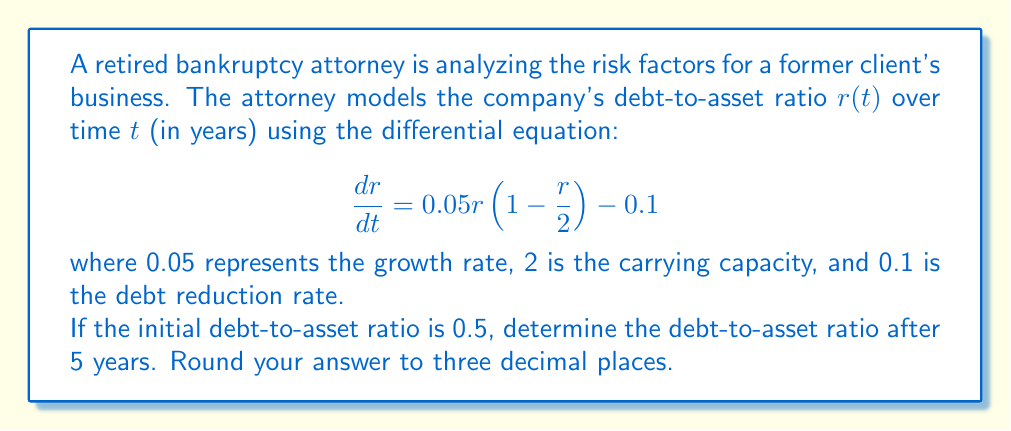Help me with this question. To solve this problem, we need to use the given differential equation and initial condition to find the debt-to-asset ratio after 5 years. This is a logistic differential equation with an additional constant term.

1. First, let's rearrange the equation:
   $$\frac{dr}{dt} = 0.05r - 0.025r^2 - 0.1$$

2. This is a Bernoulli differential equation. We can solve it by using the substitution $u = r^{-1}$:
   $$\frac{du}{dt} = -0.05u + 0.025 + 0.1u^2$$

3. This is now a linear first-order differential equation. The general solution is:
   $$u(t) = \frac{1}{0.05}\left(0.5 + C e^{0.05t}\right)$$
   where $C$ is a constant determined by the initial condition.

4. Substituting back $r = u^{-1}$:
   $$r(t) = \frac{2}{1 + 2C e^{0.05t}}$$

5. Using the initial condition $r(0) = 0.5$, we can find $C$:
   $$0.5 = \frac{2}{1 + 2C} \implies C = 1.5$$

6. The particular solution is:
   $$r(t) = \frac{2}{1 + 3e^{0.05t}}$$

7. To find the debt-to-asset ratio after 5 years, we evaluate $r(5)$:
   $$r(5) = \frac{2}{1 + 3e^{0.05(5)}} \approx 0.614$$
Answer: The debt-to-asset ratio after 5 years is approximately 0.614. 